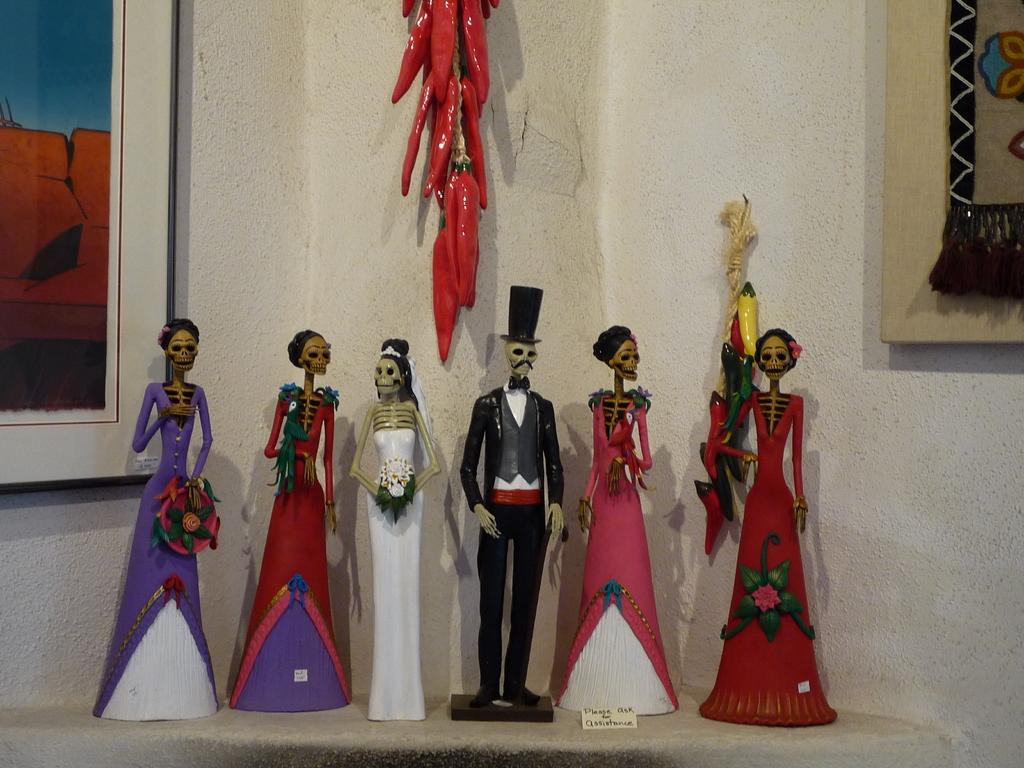What is on the table in the image? There are toys on the table. What can be seen on the wall in the background? There are frames on the wall in the background. What else is hanging in the background? There are objects hanging in the background. What type of shade is provided by the objects hanging in the background? There is no mention of shade or any objects that could provide shade in the image. 